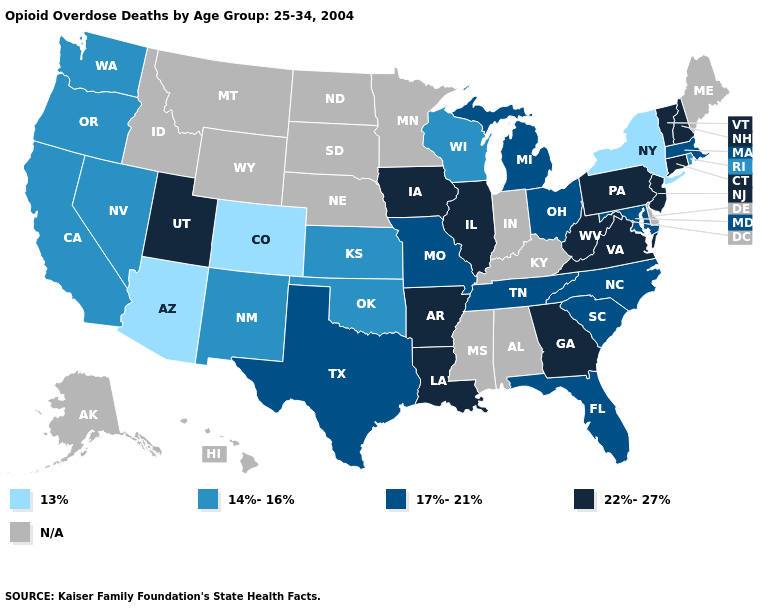What is the value of New York?
Write a very short answer. 13%. Name the states that have a value in the range 14%-16%?
Give a very brief answer. California, Kansas, Nevada, New Mexico, Oklahoma, Oregon, Rhode Island, Washington, Wisconsin. Name the states that have a value in the range 22%-27%?
Quick response, please. Arkansas, Connecticut, Georgia, Illinois, Iowa, Louisiana, New Hampshire, New Jersey, Pennsylvania, Utah, Vermont, Virginia, West Virginia. What is the value of Colorado?
Keep it brief. 13%. Which states have the lowest value in the USA?
Concise answer only. Arizona, Colorado, New York. What is the lowest value in the MidWest?
Short answer required. 14%-16%. What is the lowest value in the USA?
Short answer required. 13%. What is the value of Missouri?
Give a very brief answer. 17%-21%. What is the value of North Dakota?
Answer briefly. N/A. What is the value of Utah?
Give a very brief answer. 22%-27%. Among the states that border Louisiana , which have the lowest value?
Quick response, please. Texas. Name the states that have a value in the range 17%-21%?
Short answer required. Florida, Maryland, Massachusetts, Michigan, Missouri, North Carolina, Ohio, South Carolina, Tennessee, Texas. What is the value of North Dakota?
Short answer required. N/A. 